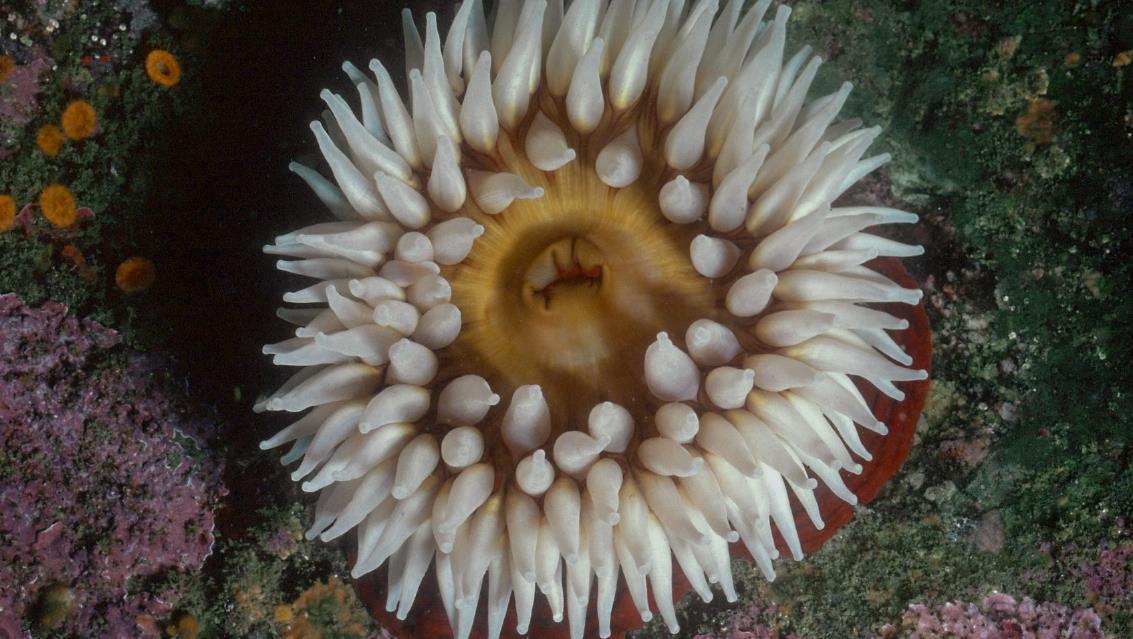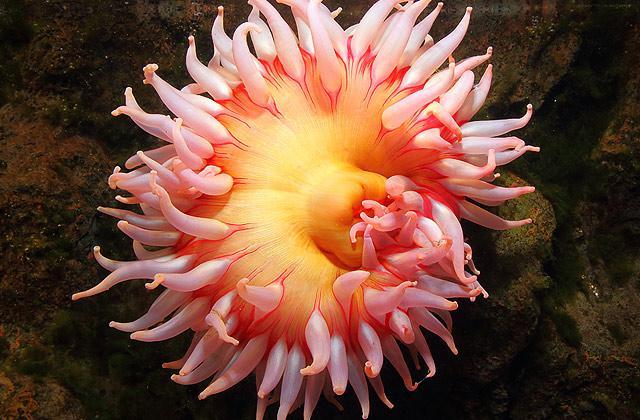The first image is the image on the left, the second image is the image on the right. Examine the images to the left and right. Is the description "There is a round anemone that is a pale peach color in the left image." accurate? Answer yes or no. No. The first image is the image on the left, the second image is the image on the right. Considering the images on both sides, is "Right and left images each show only one flower-shaped anemone with tendrils spreading out like petals, and the anemones do not share the same color." valid? Answer yes or no. Yes. 